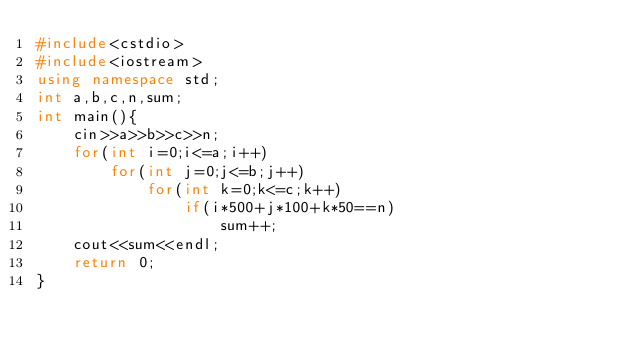Convert code to text. <code><loc_0><loc_0><loc_500><loc_500><_C++_>#include<cstdio>
#include<iostream>
using namespace std;
int a,b,c,n,sum;
int main(){
	cin>>a>>b>>c>>n;
	for(int i=0;i<=a;i++)
		for(int j=0;j<=b;j++)
			for(int k=0;k<=c;k++)
				if(i*500+j*100+k*50==n)
					sum++;
	cout<<sum<<endl;
	return 0;
}</code> 